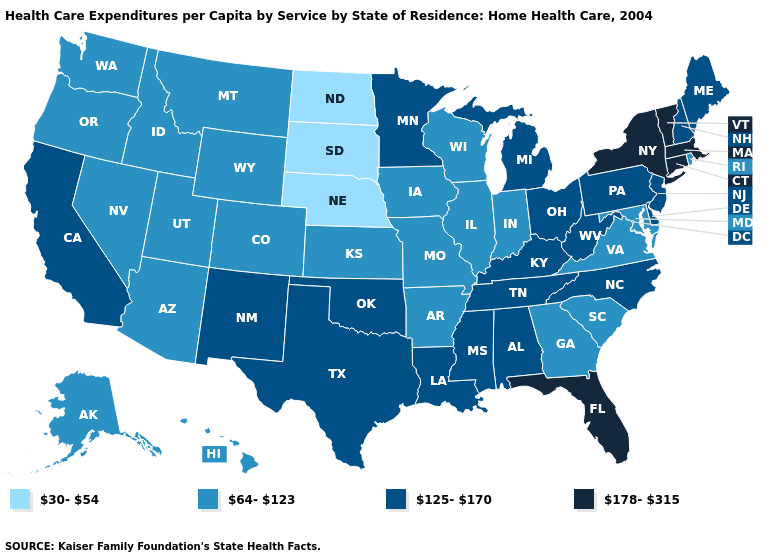What is the lowest value in states that border Connecticut?
Answer briefly. 64-123. Does North Dakota have the same value as Tennessee?
Give a very brief answer. No. Name the states that have a value in the range 30-54?
Quick response, please. Nebraska, North Dakota, South Dakota. What is the value of Oregon?
Concise answer only. 64-123. Name the states that have a value in the range 178-315?
Write a very short answer. Connecticut, Florida, Massachusetts, New York, Vermont. What is the lowest value in the USA?
Give a very brief answer. 30-54. Which states have the lowest value in the Northeast?
Concise answer only. Rhode Island. What is the value of Iowa?
Answer briefly. 64-123. Is the legend a continuous bar?
Give a very brief answer. No. What is the highest value in states that border West Virginia?
Give a very brief answer. 125-170. Does Vermont have the lowest value in the USA?
Keep it brief. No. What is the value of Maryland?
Write a very short answer. 64-123. What is the value of Texas?
Write a very short answer. 125-170. What is the value of Michigan?
Answer briefly. 125-170. What is the highest value in the USA?
Quick response, please. 178-315. 